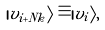Convert formula to latex. <formula><loc_0><loc_0><loc_500><loc_500>| v _ { i + N k } \rangle \equiv | v _ { i } \rangle ,</formula> 